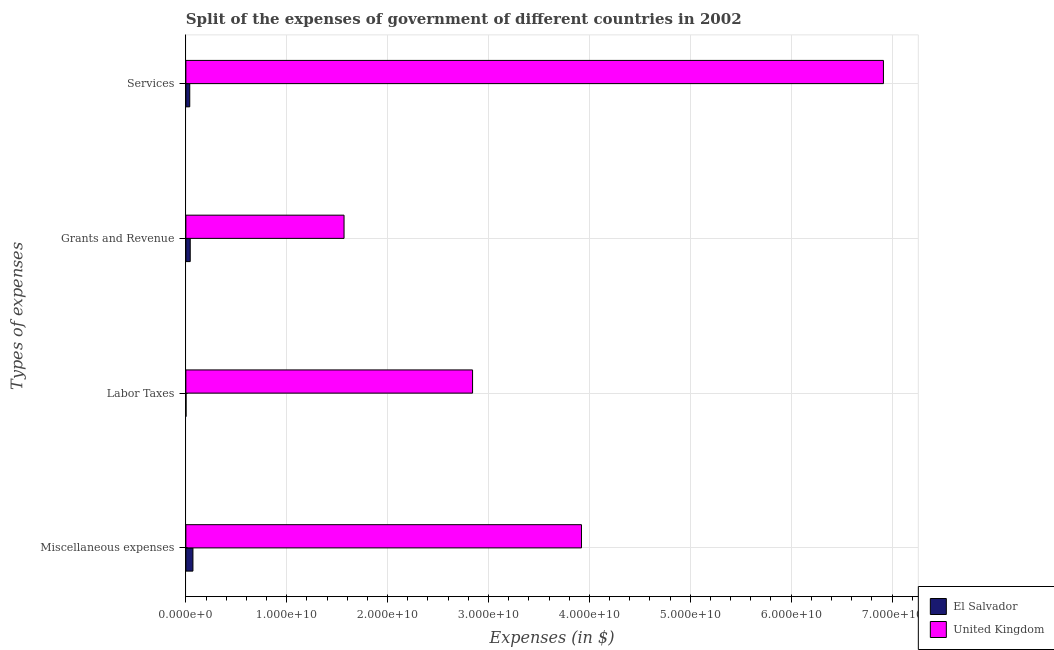Are the number of bars on each tick of the Y-axis equal?
Your answer should be very brief. Yes. How many bars are there on the 1st tick from the top?
Provide a succinct answer. 2. What is the label of the 3rd group of bars from the top?
Your response must be concise. Labor Taxes. What is the amount spent on services in El Salvador?
Your answer should be very brief. 3.84e+08. Across all countries, what is the maximum amount spent on grants and revenue?
Give a very brief answer. 1.57e+1. Across all countries, what is the minimum amount spent on services?
Ensure brevity in your answer.  3.84e+08. In which country was the amount spent on miscellaneous expenses maximum?
Your response must be concise. United Kingdom. In which country was the amount spent on services minimum?
Your answer should be compact. El Salvador. What is the total amount spent on grants and revenue in the graph?
Your response must be concise. 1.61e+1. What is the difference between the amount spent on labor taxes in El Salvador and that in United Kingdom?
Your answer should be very brief. -2.84e+1. What is the difference between the amount spent on grants and revenue in United Kingdom and the amount spent on miscellaneous expenses in El Salvador?
Keep it short and to the point. 1.50e+1. What is the average amount spent on services per country?
Give a very brief answer. 3.48e+1. What is the difference between the amount spent on grants and revenue and amount spent on labor taxes in El Salvador?
Your answer should be very brief. 4.17e+08. What is the ratio of the amount spent on grants and revenue in El Salvador to that in United Kingdom?
Give a very brief answer. 0.03. Is the difference between the amount spent on miscellaneous expenses in El Salvador and United Kingdom greater than the difference between the amount spent on grants and revenue in El Salvador and United Kingdom?
Your answer should be very brief. No. What is the difference between the highest and the second highest amount spent on miscellaneous expenses?
Ensure brevity in your answer.  3.85e+1. What is the difference between the highest and the lowest amount spent on grants and revenue?
Your answer should be compact. 1.52e+1. What does the 1st bar from the bottom in Grants and Revenue represents?
Your answer should be compact. El Salvador. Is it the case that in every country, the sum of the amount spent on miscellaneous expenses and amount spent on labor taxes is greater than the amount spent on grants and revenue?
Offer a very short reply. Yes. How many bars are there?
Provide a succinct answer. 8. What is the difference between two consecutive major ticks on the X-axis?
Offer a terse response. 1.00e+1. Are the values on the major ticks of X-axis written in scientific E-notation?
Your answer should be very brief. Yes. Where does the legend appear in the graph?
Ensure brevity in your answer.  Bottom right. What is the title of the graph?
Your response must be concise. Split of the expenses of government of different countries in 2002. Does "Lesotho" appear as one of the legend labels in the graph?
Make the answer very short. No. What is the label or title of the X-axis?
Your answer should be very brief. Expenses (in $). What is the label or title of the Y-axis?
Give a very brief answer. Types of expenses. What is the Expenses (in $) of El Salvador in Miscellaneous expenses?
Provide a succinct answer. 7.00e+08. What is the Expenses (in $) in United Kingdom in Miscellaneous expenses?
Offer a very short reply. 3.92e+1. What is the Expenses (in $) in El Salvador in Labor Taxes?
Offer a terse response. 1.48e+07. What is the Expenses (in $) in United Kingdom in Labor Taxes?
Provide a short and direct response. 2.84e+1. What is the Expenses (in $) in El Salvador in Grants and Revenue?
Offer a terse response. 4.32e+08. What is the Expenses (in $) in United Kingdom in Grants and Revenue?
Provide a short and direct response. 1.57e+1. What is the Expenses (in $) of El Salvador in Services?
Your answer should be very brief. 3.84e+08. What is the Expenses (in $) of United Kingdom in Services?
Give a very brief answer. 6.91e+1. Across all Types of expenses, what is the maximum Expenses (in $) of El Salvador?
Keep it short and to the point. 7.00e+08. Across all Types of expenses, what is the maximum Expenses (in $) in United Kingdom?
Ensure brevity in your answer.  6.91e+1. Across all Types of expenses, what is the minimum Expenses (in $) in El Salvador?
Provide a short and direct response. 1.48e+07. Across all Types of expenses, what is the minimum Expenses (in $) in United Kingdom?
Your answer should be very brief. 1.57e+1. What is the total Expenses (in $) of El Salvador in the graph?
Your response must be concise. 1.53e+09. What is the total Expenses (in $) in United Kingdom in the graph?
Give a very brief answer. 1.52e+11. What is the difference between the Expenses (in $) of El Salvador in Miscellaneous expenses and that in Labor Taxes?
Your response must be concise. 6.86e+08. What is the difference between the Expenses (in $) of United Kingdom in Miscellaneous expenses and that in Labor Taxes?
Your response must be concise. 1.08e+1. What is the difference between the Expenses (in $) of El Salvador in Miscellaneous expenses and that in Grants and Revenue?
Your answer should be compact. 2.69e+08. What is the difference between the Expenses (in $) in United Kingdom in Miscellaneous expenses and that in Grants and Revenue?
Provide a short and direct response. 2.35e+1. What is the difference between the Expenses (in $) of El Salvador in Miscellaneous expenses and that in Services?
Your answer should be very brief. 3.16e+08. What is the difference between the Expenses (in $) of United Kingdom in Miscellaneous expenses and that in Services?
Offer a terse response. -2.99e+1. What is the difference between the Expenses (in $) of El Salvador in Labor Taxes and that in Grants and Revenue?
Give a very brief answer. -4.17e+08. What is the difference between the Expenses (in $) in United Kingdom in Labor Taxes and that in Grants and Revenue?
Your answer should be very brief. 1.27e+1. What is the difference between the Expenses (in $) in El Salvador in Labor Taxes and that in Services?
Your response must be concise. -3.70e+08. What is the difference between the Expenses (in $) of United Kingdom in Labor Taxes and that in Services?
Provide a short and direct response. -4.07e+1. What is the difference between the Expenses (in $) of El Salvador in Grants and Revenue and that in Services?
Offer a very short reply. 4.73e+07. What is the difference between the Expenses (in $) of United Kingdom in Grants and Revenue and that in Services?
Provide a short and direct response. -5.35e+1. What is the difference between the Expenses (in $) of El Salvador in Miscellaneous expenses and the Expenses (in $) of United Kingdom in Labor Taxes?
Provide a succinct answer. -2.77e+1. What is the difference between the Expenses (in $) in El Salvador in Miscellaneous expenses and the Expenses (in $) in United Kingdom in Grants and Revenue?
Make the answer very short. -1.50e+1. What is the difference between the Expenses (in $) of El Salvador in Miscellaneous expenses and the Expenses (in $) of United Kingdom in Services?
Provide a succinct answer. -6.84e+1. What is the difference between the Expenses (in $) in El Salvador in Labor Taxes and the Expenses (in $) in United Kingdom in Grants and Revenue?
Your answer should be compact. -1.57e+1. What is the difference between the Expenses (in $) of El Salvador in Labor Taxes and the Expenses (in $) of United Kingdom in Services?
Make the answer very short. -6.91e+1. What is the difference between the Expenses (in $) in El Salvador in Grants and Revenue and the Expenses (in $) in United Kingdom in Services?
Your answer should be very brief. -6.87e+1. What is the average Expenses (in $) of El Salvador per Types of expenses?
Offer a terse response. 3.83e+08. What is the average Expenses (in $) of United Kingdom per Types of expenses?
Offer a very short reply. 3.81e+1. What is the difference between the Expenses (in $) in El Salvador and Expenses (in $) in United Kingdom in Miscellaneous expenses?
Give a very brief answer. -3.85e+1. What is the difference between the Expenses (in $) of El Salvador and Expenses (in $) of United Kingdom in Labor Taxes?
Make the answer very short. -2.84e+1. What is the difference between the Expenses (in $) of El Salvador and Expenses (in $) of United Kingdom in Grants and Revenue?
Your answer should be very brief. -1.52e+1. What is the difference between the Expenses (in $) of El Salvador and Expenses (in $) of United Kingdom in Services?
Ensure brevity in your answer.  -6.88e+1. What is the ratio of the Expenses (in $) of El Salvador in Miscellaneous expenses to that in Labor Taxes?
Your answer should be compact. 47.32. What is the ratio of the Expenses (in $) of United Kingdom in Miscellaneous expenses to that in Labor Taxes?
Your answer should be compact. 1.38. What is the ratio of the Expenses (in $) of El Salvador in Miscellaneous expenses to that in Grants and Revenue?
Keep it short and to the point. 1.62. What is the ratio of the Expenses (in $) of United Kingdom in Miscellaneous expenses to that in Grants and Revenue?
Make the answer very short. 2.5. What is the ratio of the Expenses (in $) in El Salvador in Miscellaneous expenses to that in Services?
Ensure brevity in your answer.  1.82. What is the ratio of the Expenses (in $) of United Kingdom in Miscellaneous expenses to that in Services?
Provide a succinct answer. 0.57. What is the ratio of the Expenses (in $) of El Salvador in Labor Taxes to that in Grants and Revenue?
Your answer should be very brief. 0.03. What is the ratio of the Expenses (in $) of United Kingdom in Labor Taxes to that in Grants and Revenue?
Your answer should be compact. 1.81. What is the ratio of the Expenses (in $) of El Salvador in Labor Taxes to that in Services?
Offer a terse response. 0.04. What is the ratio of the Expenses (in $) of United Kingdom in Labor Taxes to that in Services?
Offer a terse response. 0.41. What is the ratio of the Expenses (in $) in El Salvador in Grants and Revenue to that in Services?
Offer a terse response. 1.12. What is the ratio of the Expenses (in $) in United Kingdom in Grants and Revenue to that in Services?
Your response must be concise. 0.23. What is the difference between the highest and the second highest Expenses (in $) in El Salvador?
Your answer should be very brief. 2.69e+08. What is the difference between the highest and the second highest Expenses (in $) in United Kingdom?
Ensure brevity in your answer.  2.99e+1. What is the difference between the highest and the lowest Expenses (in $) of El Salvador?
Keep it short and to the point. 6.86e+08. What is the difference between the highest and the lowest Expenses (in $) of United Kingdom?
Provide a short and direct response. 5.35e+1. 